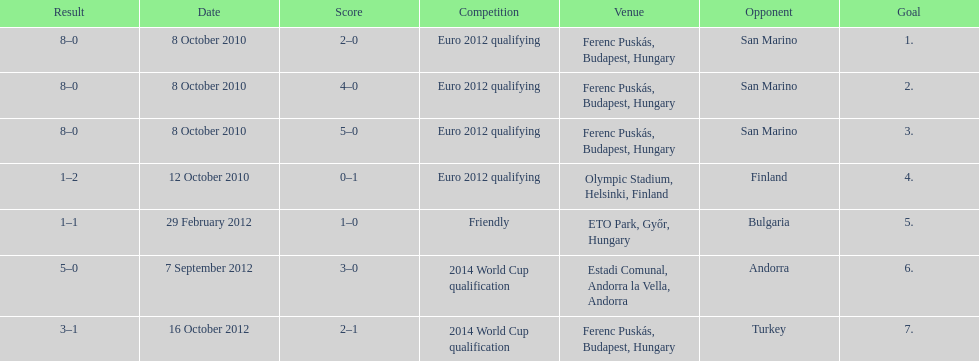When did ádám szalai make his first international goal? 8 October 2010. 